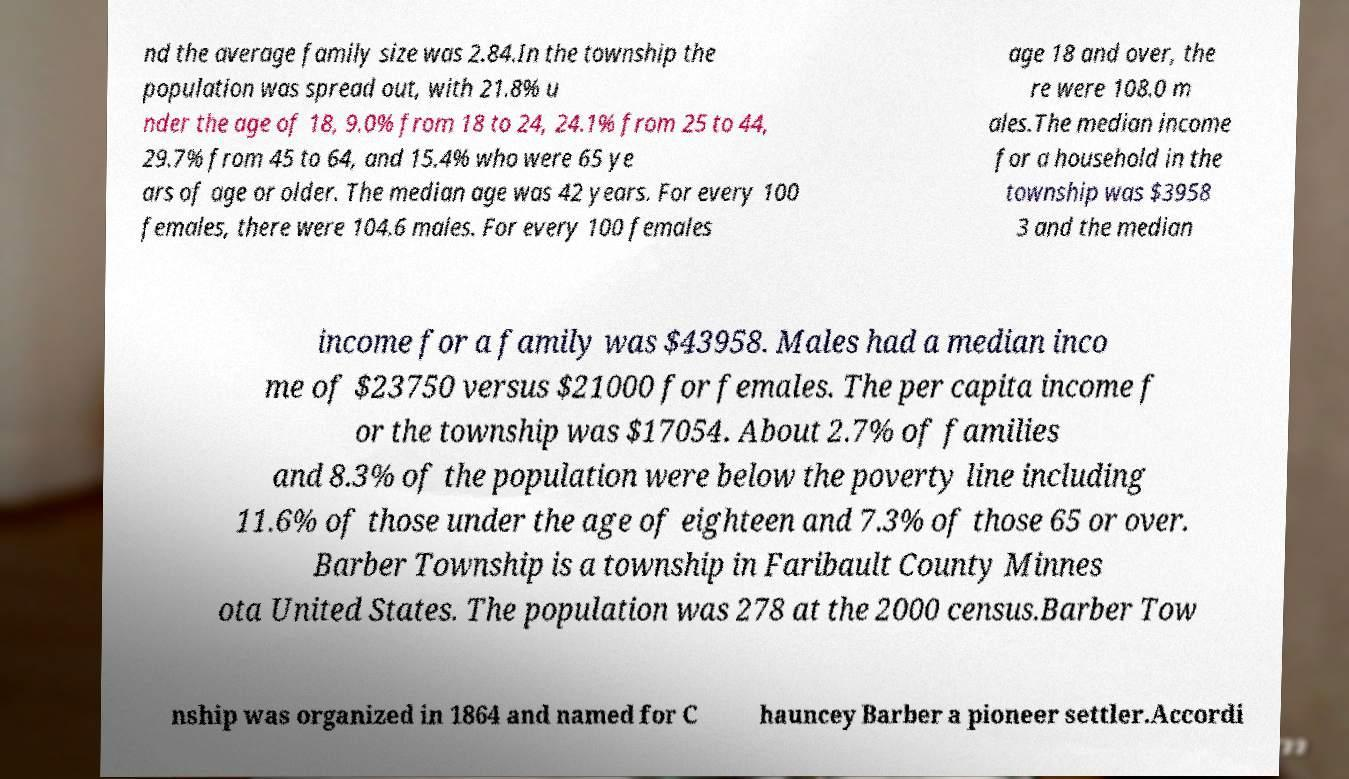Can you accurately transcribe the text from the provided image for me? nd the average family size was 2.84.In the township the population was spread out, with 21.8% u nder the age of 18, 9.0% from 18 to 24, 24.1% from 25 to 44, 29.7% from 45 to 64, and 15.4% who were 65 ye ars of age or older. The median age was 42 years. For every 100 females, there were 104.6 males. For every 100 females age 18 and over, the re were 108.0 m ales.The median income for a household in the township was $3958 3 and the median income for a family was $43958. Males had a median inco me of $23750 versus $21000 for females. The per capita income f or the township was $17054. About 2.7% of families and 8.3% of the population were below the poverty line including 11.6% of those under the age of eighteen and 7.3% of those 65 or over. Barber Township is a township in Faribault County Minnes ota United States. The population was 278 at the 2000 census.Barber Tow nship was organized in 1864 and named for C hauncey Barber a pioneer settler.Accordi 